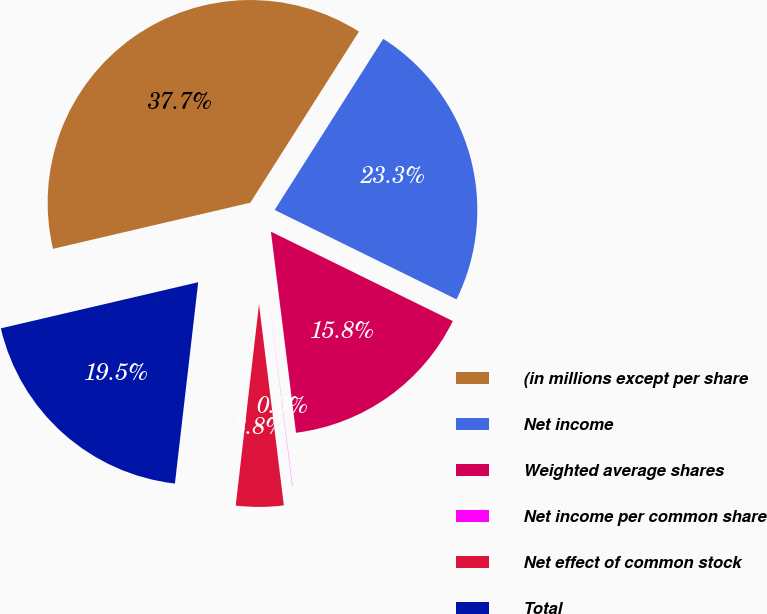Convert chart. <chart><loc_0><loc_0><loc_500><loc_500><pie_chart><fcel>(in millions except per share<fcel>Net income<fcel>Weighted average shares<fcel>Net income per common share<fcel>Net effect of common stock<fcel>Total<nl><fcel>37.65%<fcel>23.27%<fcel>15.75%<fcel>0.02%<fcel>3.79%<fcel>19.51%<nl></chart> 